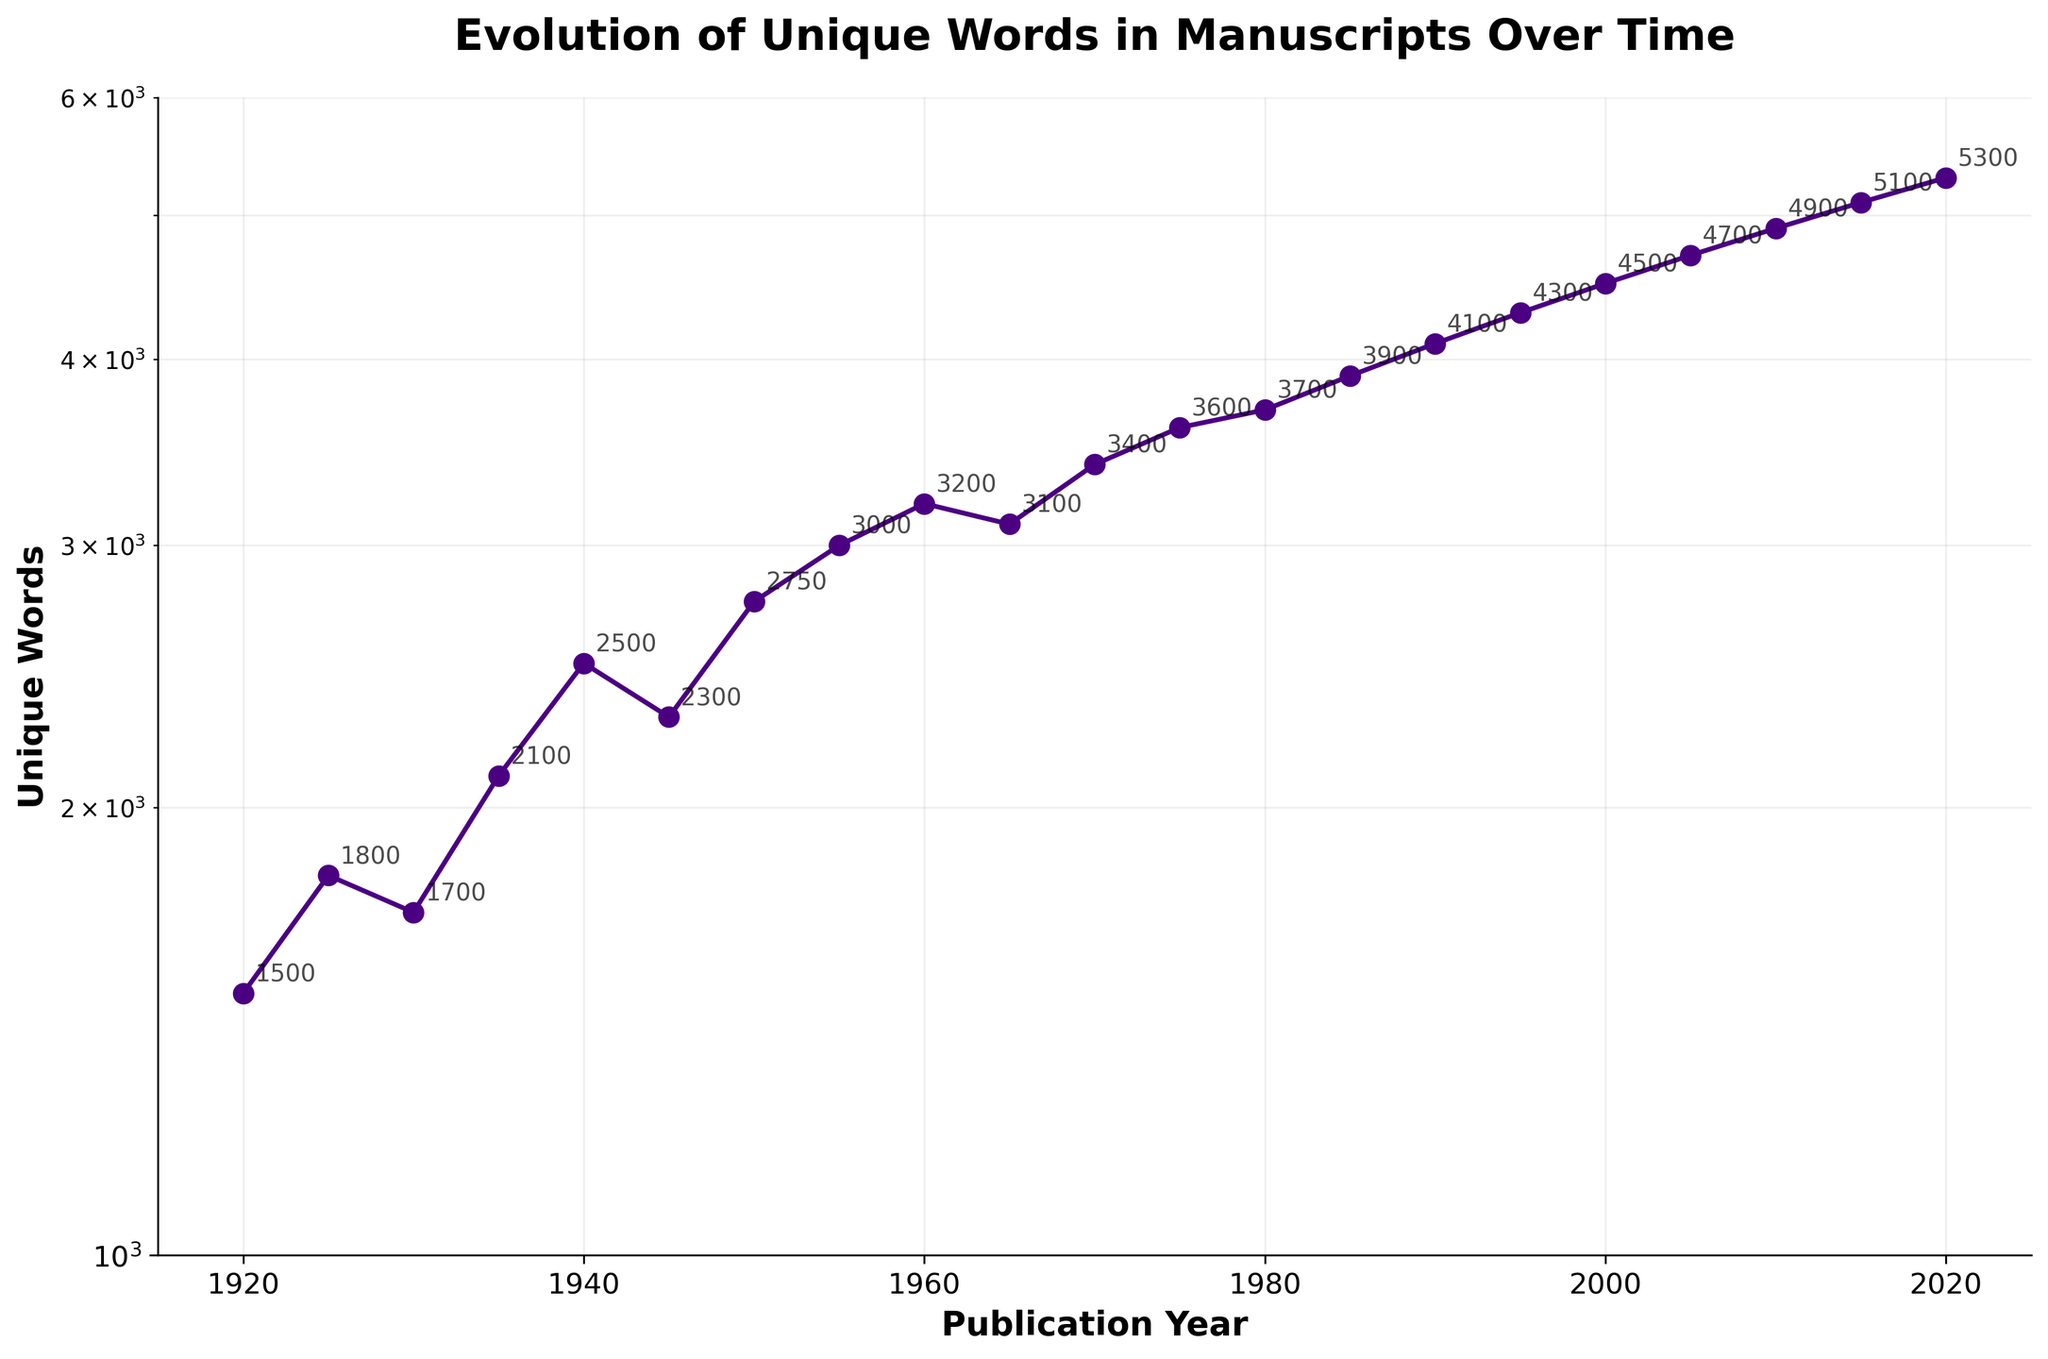What is the title of the plot? The title of the plot is displayed at the top of the figure. It reads "Evolution of Unique Words in Manuscripts Over Time".
Answer: Evolution of Unique Words in Manuscripts Over Time How many years are shown in the plot? By counting the x-axis labels or data points, we can see that there are data points for each publication year from 1920 to 2020, inclusive. Therefore, there are 21 years shown in the plot.
Answer: 21 What is the approximate number of unique words in the year 1945? Locate the data point for the year 1945 on the x-axis and read the corresponding y-axis value. The annotation shows approximately 2300 unique words in 1945.
Answer: 2300 In which year did the number of unique words first exceed 3000? Identify the data point where the unique words value exceeds 3000. This occurs in the year 1955.
Answer: 1955 What is the general trend of unique words from 1920 to 2020? Observe the overall direction of the data points on the plot. The plot shows an increasing trend in the number of unique words over time.
Answer: Increasing Which year has the highest number of unique words? Identify the data point with the highest y-value. The year 2020 has the highest number of unique words, with 5300.
Answer: 2020 How much did the number of unique words increase from 1920 to 1980? Subtract the number of unique words in 1920 from the number in 1980. The values are 3700 (1980) and 1500 (1920), so the increase is 3700 - 1500 = 2200.
Answer: 2200 By what percentage did the number of unique words change from 2005 to 2015? Calculate the percentage change using the formula: ((words_2015 - words_2005) / words_2005) * 100. The values are 5100 (2015) and 4700 (2005), so the change is ((5100 - 4700) / 4700) * 100 = 8.51%.
Answer: 8.51% Which decade saw the biggest increase in the number of unique words? Compare the differences in unique word counts for each decade: 1920s (300), 1930s (1000), 1940s (700), 1950s (1200), 1960s (200), 1970s (600), 1980s (2000), 1990s (200), 2000s (500), 2010s (200). The 1980s saw the largest increase with 2000.
Answer: 1980s Does the plot use a linear or logarithmic scale on the y-axis? The plot is labeled "semilogy", indicating it uses a logarithmic scale on the y-axis.
Answer: Logarithmic 